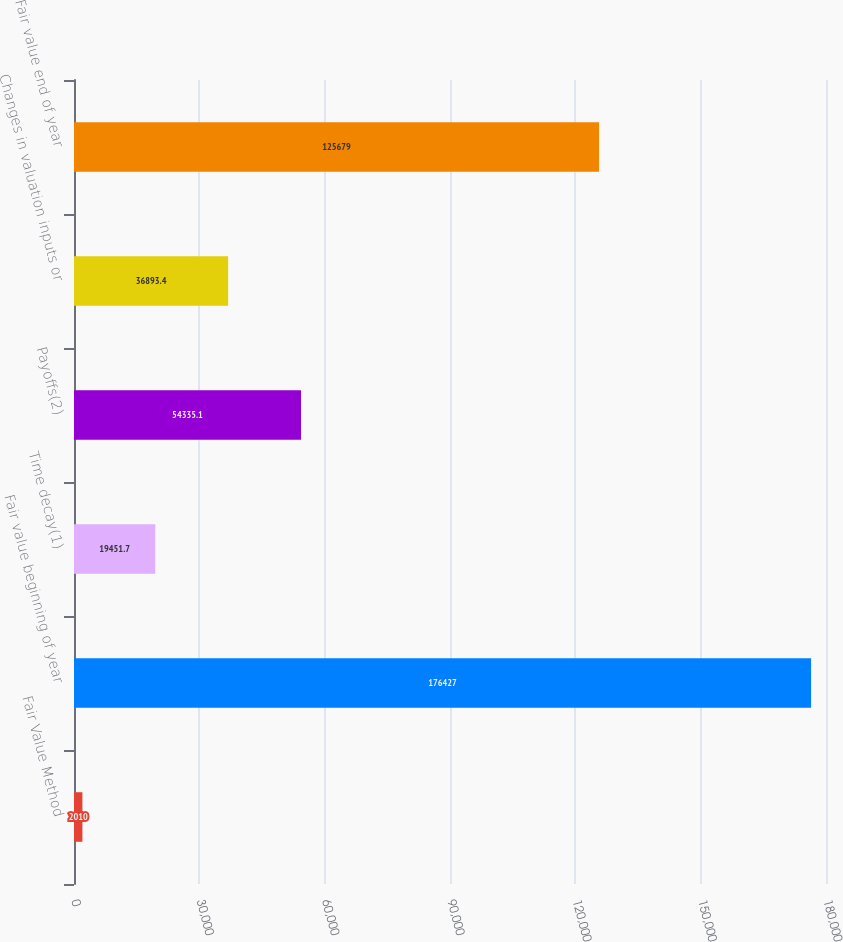Convert chart to OTSL. <chart><loc_0><loc_0><loc_500><loc_500><bar_chart><fcel>Fair Value Method<fcel>Fair value beginning of year<fcel>Time decay(1)<fcel>Payoffs(2)<fcel>Changes in valuation inputs or<fcel>Fair value end of year<nl><fcel>2010<fcel>176427<fcel>19451.7<fcel>54335.1<fcel>36893.4<fcel>125679<nl></chart> 